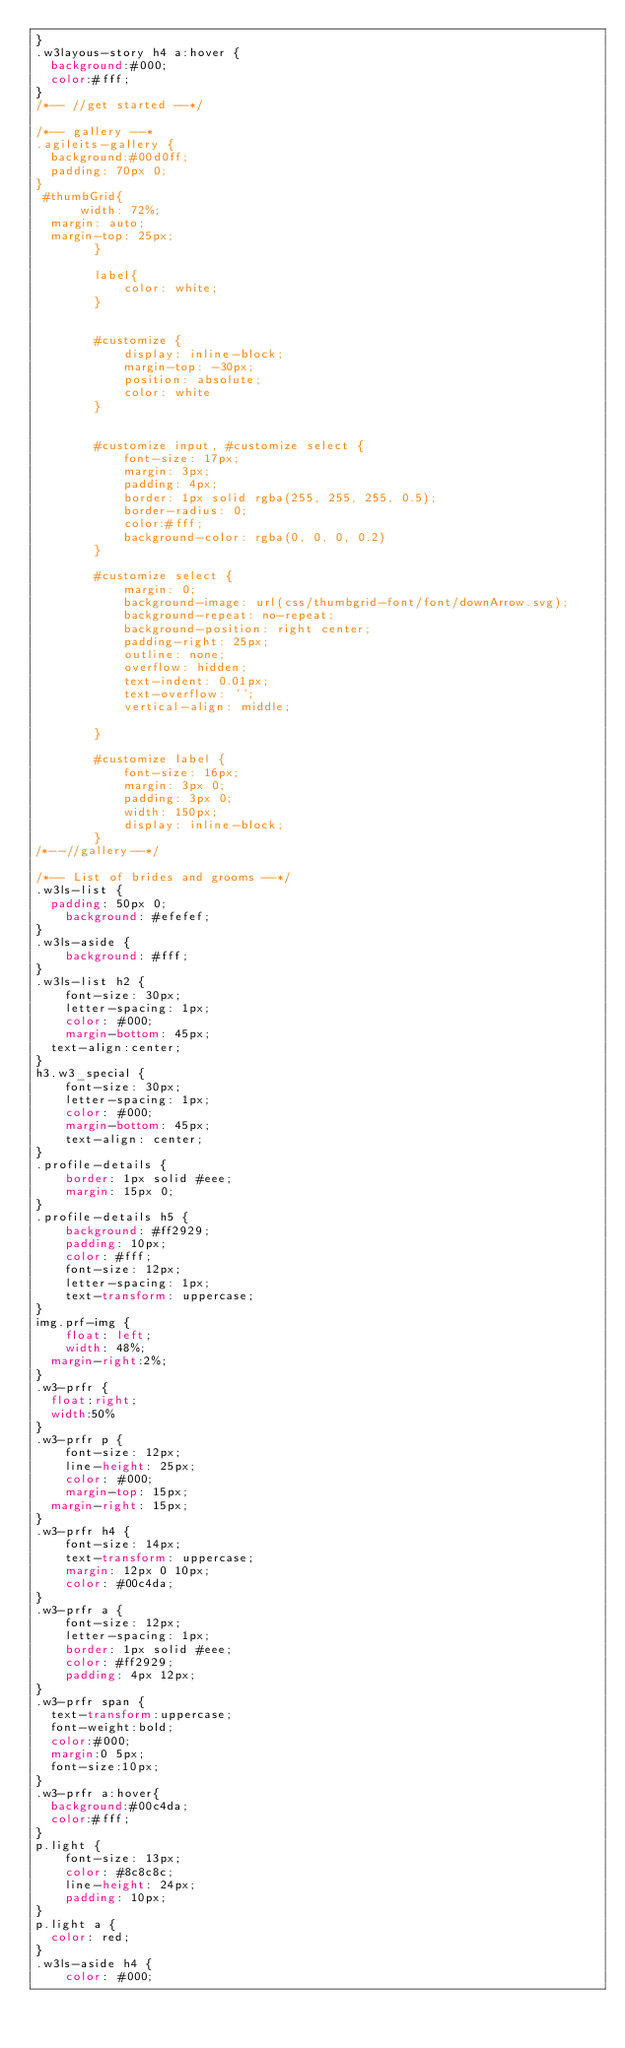Convert code to text. <code><loc_0><loc_0><loc_500><loc_500><_CSS_>}
.w3layous-story h4 a:hover {
	background:#000;
	color:#fff;
}
/*-- //get started --*/

/*-- gallery --*
.agileits-gallery {
	background:#00d0ff;
	padding: 70px 0;
}
 #thumbGrid{
      width: 72%;
  margin: auto;
  margin-top: 25px;
        }

        label{
            color: white;
        }


        #customize {
            display: inline-block;
            margin-top: -30px;
            position: absolute;
            color: white
        }


        #customize input, #customize select {
            font-size: 17px;
            margin: 3px;
            padding: 4px;
            border: 1px solid rgba(255, 255, 255, 0.5);
            border-radius: 0;
            color:#fff;
            background-color: rgba(0, 0, 0, 0.2)
        }

        #customize select {
            margin: 0;
            background-image: url(css/thumbgrid-font/font/downArrow.svg);
            background-repeat: no-repeat;
            background-position: right center;
            padding-right: 25px;
            outline: none;
            overflow: hidden;
            text-indent: 0.01px;
            text-overflow: '';
            vertical-align: middle;

        }

        #customize label {
            font-size: 16px;
            margin: 3px 0;
            padding: 3px 0;
            width: 150px;
            display: inline-block;
        }
/*--//gallery--*/	

/*-- List of brides and grooms --*/
.w3ls-list {
	padding: 50px 0;
    background: #efefef;
}
.w3ls-aside {
    background: #fff;
}
.w3ls-list h2 {
    font-size: 30px;
    letter-spacing: 1px;
    color: #000;
    margin-bottom: 45px;
	text-align:center;
}
h3.w3_special {
    font-size: 30px;
    letter-spacing: 1px;
    color: #000;
    margin-bottom: 45px;
    text-align: center;
}
.profile-details {
    border: 1px solid #eee;
    margin: 15px 0;
}
.profile-details h5 {
    background: #ff2929;
    padding: 10px;
    color: #fff;
    font-size: 12px;
    letter-spacing: 1px;
    text-transform: uppercase;
}
img.prf-img {
    float: left;
    width: 48%;
	margin-right:2%;
}
.w3-prfr {
	float:right;
	width:50%
}
.w3-prfr p {
    font-size: 12px;
    line-height: 25px;
    color: #000;
    margin-top: 15px;
	margin-right: 15px;
}
.w3-prfr h4 {
    font-size: 14px;
    text-transform: uppercase;
    margin: 12px 0 10px;
    color: #00c4da;
}
.w3-prfr a {
    font-size: 12px;
    letter-spacing: 1px;
    border: 1px solid #eee;
    color: #ff2929;
    padding: 4px 12px;
}
.w3-prfr span {
	text-transform:uppercase;
	font-weight:bold;
	color:#000;
	margin:0 5px;
	font-size:10px;
}
.w3-prfr a:hover{
	background:#00c4da;
	color:#fff;
}
p.light {
    font-size: 13px;
    color: #8c8c8c;
    line-height: 24px;
    padding: 10px;
}
p.light a {
	color: red;
}
.w3ls-aside h4 {
    color: #000;</code> 